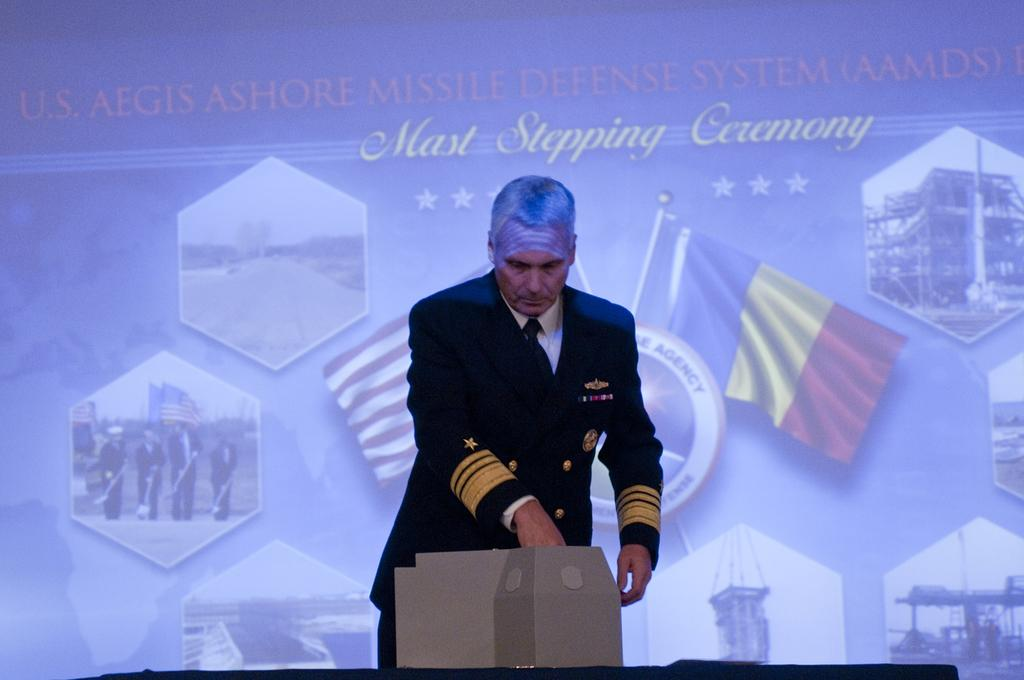What is the person in the image wearing? The person is wearing a uniform in the image. Where is the person located in the image? The person is in the center of the image. What object can be seen on a table in the image? There is a box on a table in the image. What can be seen in the background of the image? There is a screen visible in the background of the image. What type of soup is being served on the chin of the person in the image? There is no soup or chin visible in the image; the person is wearing a uniform and is not depicted as eating or having soup on their chin. 